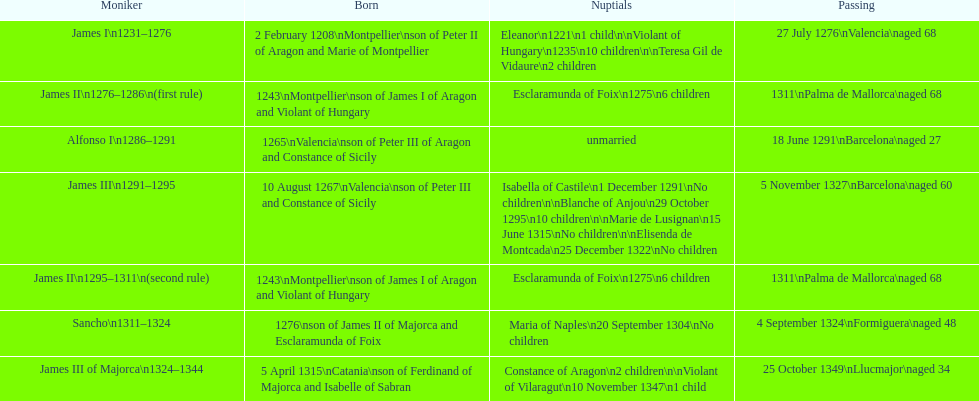James i and james ii both died at what age? 68. 